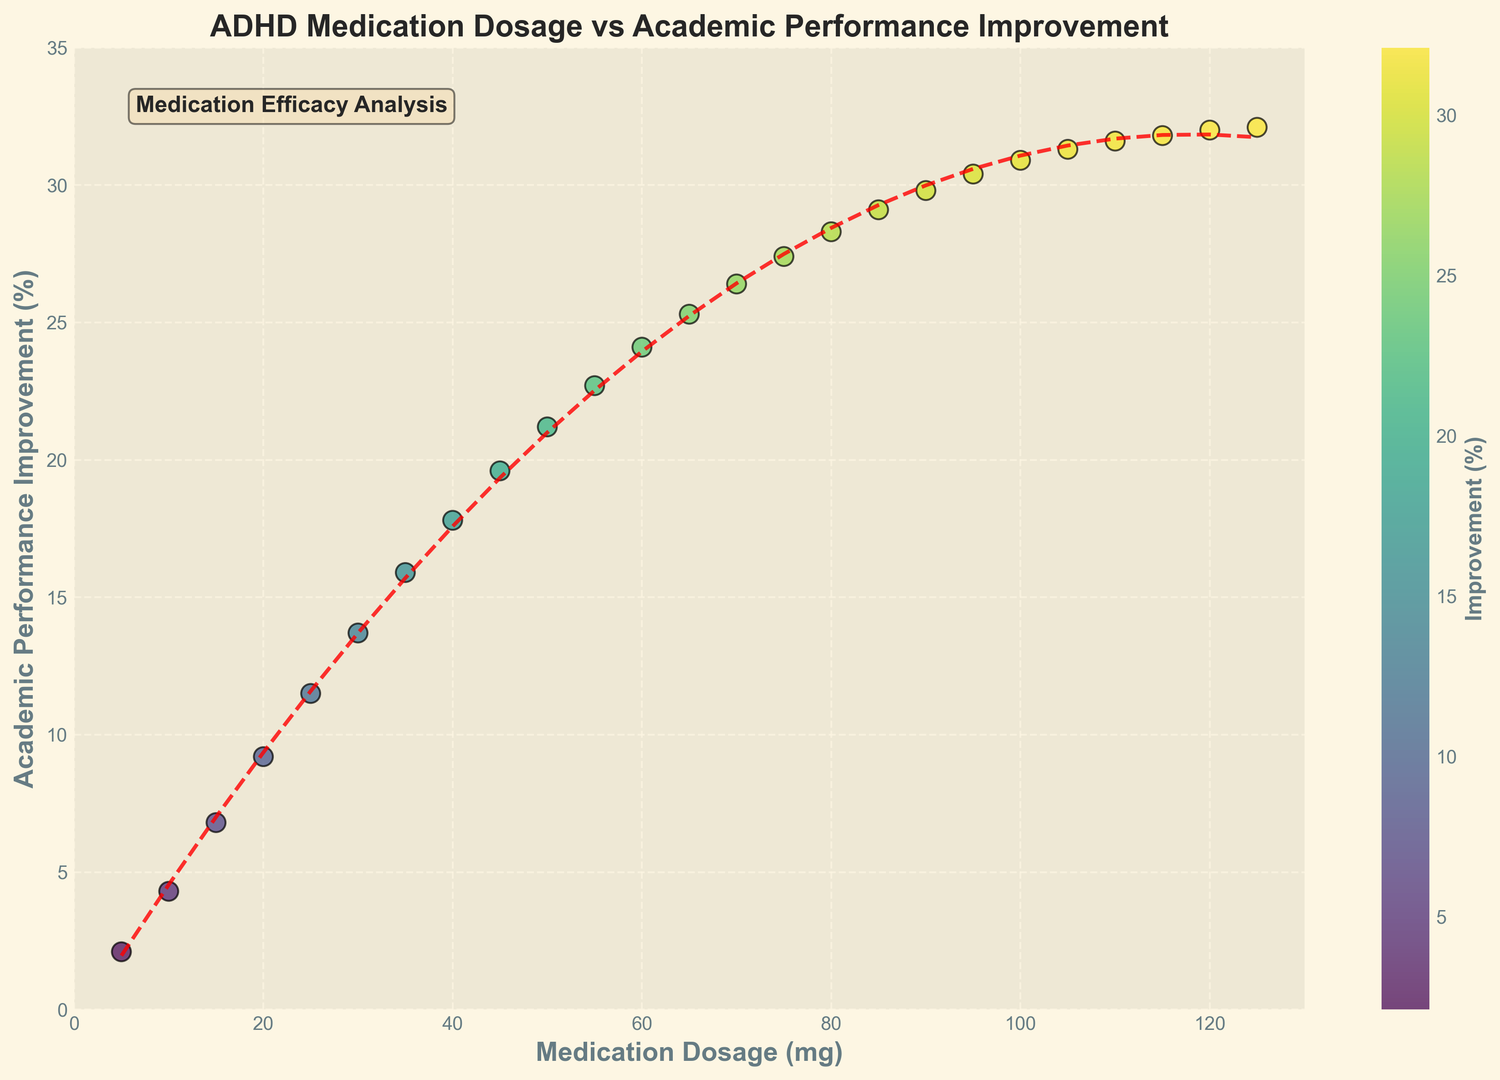What's the correlation between medication dosage and academic performance improvement? From the scatter plot, there is a clear upward trend in academic performance improvement as the medication dosage increases, indicating a positive correlation. The trend line also reinforces this relationship.
Answer: Positive What is the academic performance improvement for a 45 mg dosage? Looking at the scatter plot, the point corresponding to a 45 mg dosage on the x-axis aligns with approximately 19.6% on the y-axis.
Answer: 19.6% Does the plot show diminishing returns in academic performance improvement at higher dosages? Yes, the scatter plot shows that academic performance improvement increases rapidly at lower dosages but starts to plateau around 100 mg and beyond, indicating diminishing returns. The trend line reinforces this observation.
Answer: Yes What is the approximate improvement percentage at the highest dosage shown (125 mg)? The point corresponding to the highest dosage of 125 mg aligns with approximately 32.1% on the y-axis in the scatter plot.
Answer: 32.1% Which dosage shows the lowest academic performance improvement, and what is the value? The scatter plot indicates that the lowest dosage of 5 mg corresponds to the lowest academic performance improvement, which is approximately 2.1%.
Answer: 5 mg, 2.1% Compare the academic performance improvement between 60 mg and 90 mg. The scatter plot shows that the academic performance improvement at 60 mg is approximately 24.1%, while at 90 mg it is approximately 29.8%. Therefore, 90 mg corresponds to a higher improvement than 60 mg.
Answer: 90 mg is higher Between which dosages does the improvement increase more rapidly than others? From the scatter plot, improvement increases most rapidly between 5 mg and 45 mg. The slope of the trend line between these points is steeper compared to other segments.
Answer: 5 mg to 45 mg What visual attribute is used to represent the improvement percentage on the scatter plot? The scatter plot uses color intensity and a color bar on the side to visually represent the improvement percentage, with darker colors indicating higher percentages.
Answer: Color intensity and color bar Is there any outlier in the data points shown in the scatter plot? There are no obvious outliers visible in the scatter plot; the points appear to follow a smooth upward trend without any anomalies.
Answer: No Based on the trend line, what general shape does the relationship between medication dosage and academic performance improvement take? The trend line fitted to the data is represented as a second-order polynomial (quadratic), indicating a curve that initially rises sharply and then begins to flatten out, forming a concave shape.
Answer: Concave quadratic 